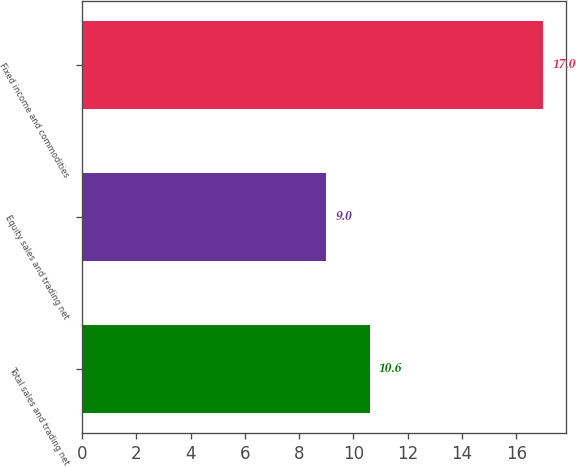Convert chart to OTSL. <chart><loc_0><loc_0><loc_500><loc_500><bar_chart><fcel>Total sales and trading net<fcel>Equity sales and trading net<fcel>Fixed income and commodities<nl><fcel>10.6<fcel>9<fcel>17<nl></chart> 